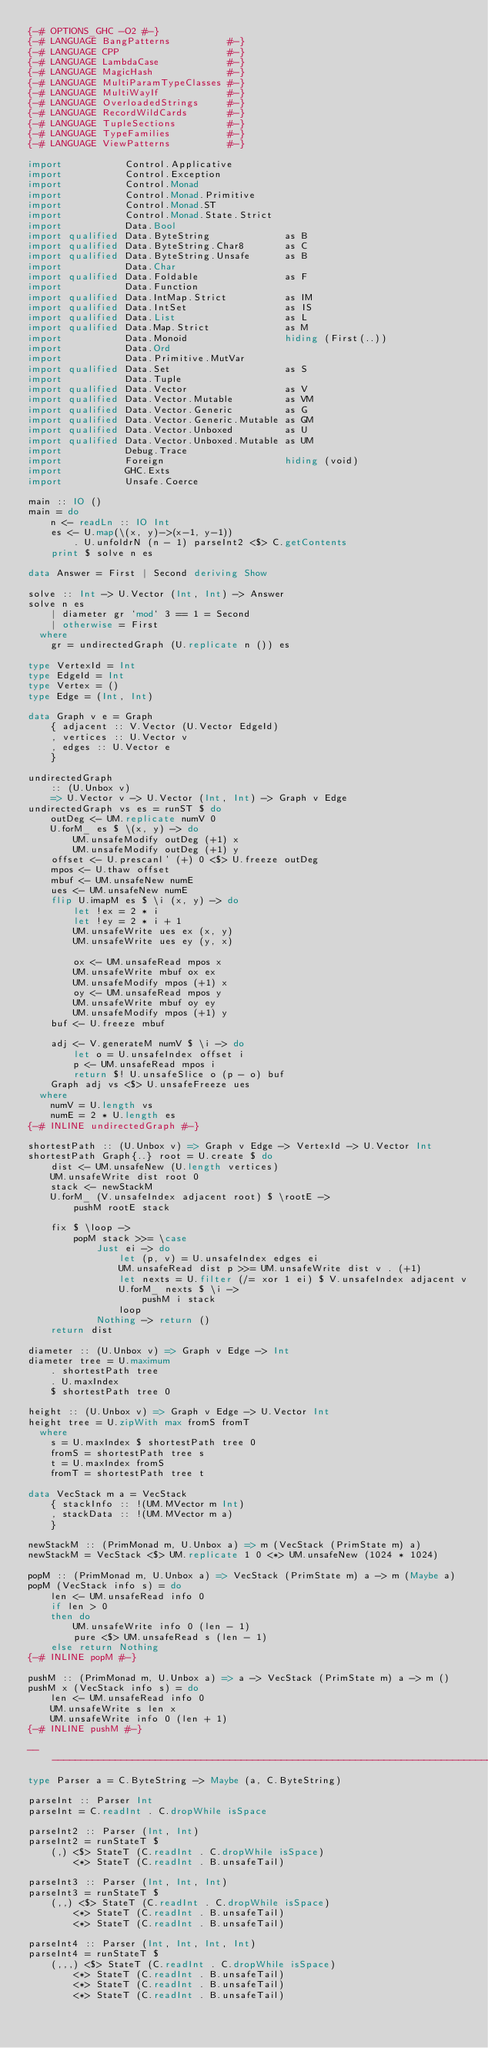Convert code to text. <code><loc_0><loc_0><loc_500><loc_500><_Haskell_>{-# OPTIONS_GHC -O2 #-}
{-# LANGUAGE BangPatterns          #-}
{-# LANGUAGE CPP                   #-}
{-# LANGUAGE LambdaCase            #-}
{-# LANGUAGE MagicHash             #-}
{-# LANGUAGE MultiParamTypeClasses #-}
{-# LANGUAGE MultiWayIf            #-}
{-# LANGUAGE OverloadedStrings     #-}
{-# LANGUAGE RecordWildCards       #-}
{-# LANGUAGE TupleSections         #-}
{-# LANGUAGE TypeFamilies          #-}
{-# LANGUAGE ViewPatterns          #-}

import           Control.Applicative
import           Control.Exception
import           Control.Monad
import           Control.Monad.Primitive
import           Control.Monad.ST
import           Control.Monad.State.Strict
import           Data.Bool
import qualified Data.ByteString             as B
import qualified Data.ByteString.Char8       as C
import qualified Data.ByteString.Unsafe      as B
import           Data.Char
import qualified Data.Foldable               as F
import           Data.Function
import qualified Data.IntMap.Strict          as IM
import qualified Data.IntSet                 as IS
import qualified Data.List                   as L
import qualified Data.Map.Strict             as M
import           Data.Monoid                 hiding (First(..))
import           Data.Ord
import           Data.Primitive.MutVar
import qualified Data.Set                    as S
import           Data.Tuple
import qualified Data.Vector                 as V
import qualified Data.Vector.Mutable         as VM
import qualified Data.Vector.Generic         as G
import qualified Data.Vector.Generic.Mutable as GM
import qualified Data.Vector.Unboxed         as U
import qualified Data.Vector.Unboxed.Mutable as UM
import           Debug.Trace
import           Foreign                     hiding (void)
import           GHC.Exts
import           Unsafe.Coerce

main :: IO ()
main = do
    n <- readLn :: IO Int
    es <- U.map(\(x, y)->(x-1, y-1))
        . U.unfoldrN (n - 1) parseInt2 <$> C.getContents
    print $ solve n es

data Answer = First | Second deriving Show

solve :: Int -> U.Vector (Int, Int) -> Answer
solve n es
    | diameter gr `mod` 3 == 1 = Second
    | otherwise = First
  where
    gr = undirectedGraph (U.replicate n ()) es

type VertexId = Int
type EdgeId = Int
type Vertex = ()
type Edge = (Int, Int)

data Graph v e = Graph
    { adjacent :: V.Vector (U.Vector EdgeId)
    , vertices :: U.Vector v
    , edges :: U.Vector e
    }

undirectedGraph
    :: (U.Unbox v)
    => U.Vector v -> U.Vector (Int, Int) -> Graph v Edge
undirectedGraph vs es = runST $ do
    outDeg <- UM.replicate numV 0
    U.forM_ es $ \(x, y) -> do
        UM.unsafeModify outDeg (+1) x
        UM.unsafeModify outDeg (+1) y
    offset <- U.prescanl' (+) 0 <$> U.freeze outDeg
    mpos <- U.thaw offset
    mbuf <- UM.unsafeNew numE
    ues <- UM.unsafeNew numE
    flip U.imapM es $ \i (x, y) -> do
        let !ex = 2 * i
        let !ey = 2 * i + 1
        UM.unsafeWrite ues ex (x, y)
        UM.unsafeWrite ues ey (y, x)

        ox <- UM.unsafeRead mpos x
        UM.unsafeWrite mbuf ox ex
        UM.unsafeModify mpos (+1) x
        oy <- UM.unsafeRead mpos y
        UM.unsafeWrite mbuf oy ey
        UM.unsafeModify mpos (+1) y
    buf <- U.freeze mbuf

    adj <- V.generateM numV $ \i -> do
        let o = U.unsafeIndex offset i
        p <- UM.unsafeRead mpos i
        return $! U.unsafeSlice o (p - o) buf
    Graph adj vs <$> U.unsafeFreeze ues
  where
    numV = U.length vs
    numE = 2 * U.length es
{-# INLINE undirectedGraph #-}

shortestPath :: (U.Unbox v) => Graph v Edge -> VertexId -> U.Vector Int
shortestPath Graph{..} root = U.create $ do
    dist <- UM.unsafeNew (U.length vertices)
    UM.unsafeWrite dist root 0
    stack <- newStackM
    U.forM_ (V.unsafeIndex adjacent root) $ \rootE ->
        pushM rootE stack

    fix $ \loop ->
        popM stack >>= \case
            Just ei -> do
                let (p, v) = U.unsafeIndex edges ei
                UM.unsafeRead dist p >>= UM.unsafeWrite dist v . (+1)
                let nexts = U.filter (/= xor 1 ei) $ V.unsafeIndex adjacent v
                U.forM_ nexts $ \i ->
                    pushM i stack
                loop
            Nothing -> return ()
    return dist

diameter :: (U.Unbox v) => Graph v Edge -> Int
diameter tree = U.maximum
    . shortestPath tree
    . U.maxIndex
    $ shortestPath tree 0

height :: (U.Unbox v) => Graph v Edge -> U.Vector Int
height tree = U.zipWith max fromS fromT
  where
    s = U.maxIndex $ shortestPath tree 0
    fromS = shortestPath tree s
    t = U.maxIndex fromS
    fromT = shortestPath tree t

data VecStack m a = VecStack
    { stackInfo :: !(UM.MVector m Int)
    , stackData :: !(UM.MVector m a)
    }

newStackM :: (PrimMonad m, U.Unbox a) => m (VecStack (PrimState m) a)
newStackM = VecStack <$> UM.replicate 1 0 <*> UM.unsafeNew (1024 * 1024)

popM :: (PrimMonad m, U.Unbox a) => VecStack (PrimState m) a -> m (Maybe a)
popM (VecStack info s) = do
    len <- UM.unsafeRead info 0
    if len > 0
    then do
        UM.unsafeWrite info 0 (len - 1)
        pure <$> UM.unsafeRead s (len - 1)
    else return Nothing
{-# INLINE popM #-}

pushM :: (PrimMonad m, U.Unbox a) => a -> VecStack (PrimState m) a -> m ()
pushM x (VecStack info s) = do
    len <- UM.unsafeRead info 0
    UM.unsafeWrite s len x
    UM.unsafeWrite info 0 (len + 1)
{-# INLINE pushM #-}

-------------------------------------------------------------------------------
type Parser a = C.ByteString -> Maybe (a, C.ByteString)

parseInt :: Parser Int
parseInt = C.readInt . C.dropWhile isSpace

parseInt2 :: Parser (Int, Int)
parseInt2 = runStateT $
    (,) <$> StateT (C.readInt . C.dropWhile isSpace)
        <*> StateT (C.readInt . B.unsafeTail)

parseInt3 :: Parser (Int, Int, Int)
parseInt3 = runStateT $
    (,,) <$> StateT (C.readInt . C.dropWhile isSpace)
        <*> StateT (C.readInt . B.unsafeTail)
        <*> StateT (C.readInt . B.unsafeTail)

parseInt4 :: Parser (Int, Int, Int, Int)
parseInt4 = runStateT $
    (,,,) <$> StateT (C.readInt . C.dropWhile isSpace)
        <*> StateT (C.readInt . B.unsafeTail)
        <*> StateT (C.readInt . B.unsafeTail)
        <*> StateT (C.readInt . B.unsafeTail)</code> 